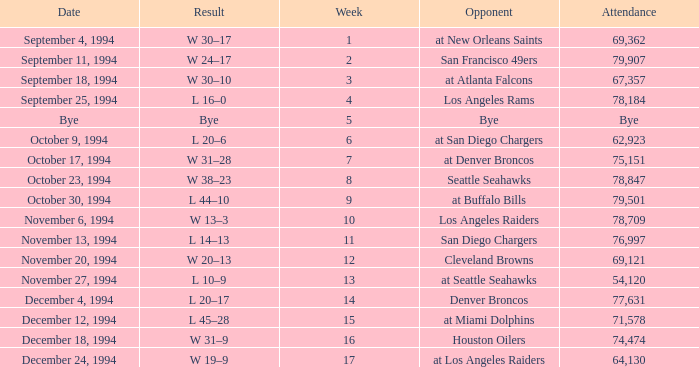What was the score of the Chiefs pre-Week 16 game that 69,362 people attended? W 30–17. Could you parse the entire table? {'header': ['Date', 'Result', 'Week', 'Opponent', 'Attendance'], 'rows': [['September 4, 1994', 'W 30–17', '1', 'at New Orleans Saints', '69,362'], ['September 11, 1994', 'W 24–17', '2', 'San Francisco 49ers', '79,907'], ['September 18, 1994', 'W 30–10', '3', 'at Atlanta Falcons', '67,357'], ['September 25, 1994', 'L 16–0', '4', 'Los Angeles Rams', '78,184'], ['Bye', 'Bye', '5', 'Bye', 'Bye'], ['October 9, 1994', 'L 20–6', '6', 'at San Diego Chargers', '62,923'], ['October 17, 1994', 'W 31–28', '7', 'at Denver Broncos', '75,151'], ['October 23, 1994', 'W 38–23', '8', 'Seattle Seahawks', '78,847'], ['October 30, 1994', 'L 44–10', '9', 'at Buffalo Bills', '79,501'], ['November 6, 1994', 'W 13–3', '10', 'Los Angeles Raiders', '78,709'], ['November 13, 1994', 'L 14–13', '11', 'San Diego Chargers', '76,997'], ['November 20, 1994', 'W 20–13', '12', 'Cleveland Browns', '69,121'], ['November 27, 1994', 'L 10–9', '13', 'at Seattle Seahawks', '54,120'], ['December 4, 1994', 'L 20–17', '14', 'Denver Broncos', '77,631'], ['December 12, 1994', 'L 45–28', '15', 'at Miami Dolphins', '71,578'], ['December 18, 1994', 'W 31–9', '16', 'Houston Oilers', '74,474'], ['December 24, 1994', 'W 19–9', '17', 'at Los Angeles Raiders', '64,130']]} 